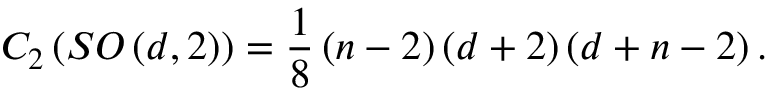Convert formula to latex. <formula><loc_0><loc_0><loc_500><loc_500>C _ { 2 } \left ( S O \left ( d , 2 \right ) \right ) = \frac { 1 } { 8 } \left ( n - 2 \right ) \left ( d + 2 \right ) \left ( d + n - 2 \right ) .</formula> 